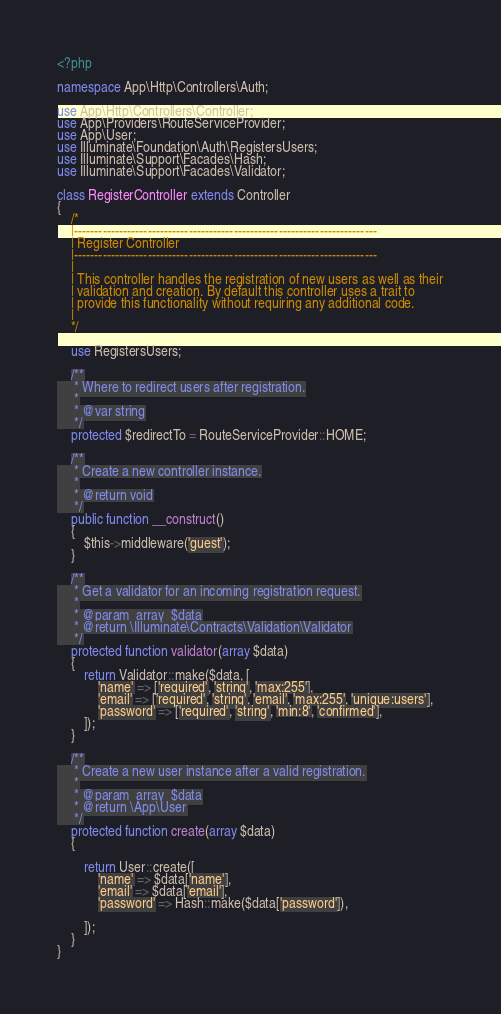Convert code to text. <code><loc_0><loc_0><loc_500><loc_500><_PHP_><?php

namespace App\Http\Controllers\Auth;

use App\Http\Controllers\Controller;
use App\Providers\RouteServiceProvider;
use App\User;
use Illuminate\Foundation\Auth\RegistersUsers;
use Illuminate\Support\Facades\Hash;
use Illuminate\Support\Facades\Validator;

class RegisterController extends Controller
{
    /*
    |--------------------------------------------------------------------------
    | Register Controller
    |--------------------------------------------------------------------------
    |
    | This controller handles the registration of new users as well as their
    | validation and creation. By default this controller uses a trait to
    | provide this functionality without requiring any additional code.
    |
    */

    use RegistersUsers;

    /**
     * Where to redirect users after registration.
     *
     * @var string
     */
    protected $redirectTo = RouteServiceProvider::HOME;

    /**
     * Create a new controller instance.
     *
     * @return void
     */
    public function __construct()
    {
        $this->middleware('guest');
    }

    /**
     * Get a validator for an incoming registration request.
     *
     * @param  array  $data
     * @return \Illuminate\Contracts\Validation\Validator
     */
    protected function validator(array $data)
    {
        return Validator::make($data, [
            'name' => ['required', 'string', 'max:255'],
            'email' => ['required', 'string', 'email', 'max:255', 'unique:users'],
            'password' => ['required', 'string', 'min:8', 'confirmed'],
        ]);
    }

    /**
     * Create a new user instance after a valid registration.
     *
     * @param  array  $data
     * @return \App\User
     */
    protected function create(array $data)
    {
        
        return User::create([
            'name' => $data['name'],
            'email' => $data['email'],
            'password' => Hash::make($data['password']),

        ]);
    }
}
</code> 